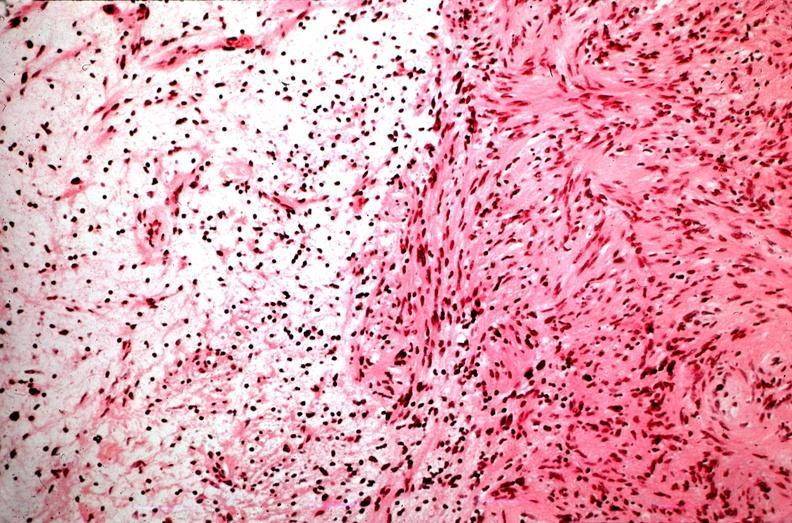what does this image show?
Answer the question using a single word or phrase. Schwannoma 